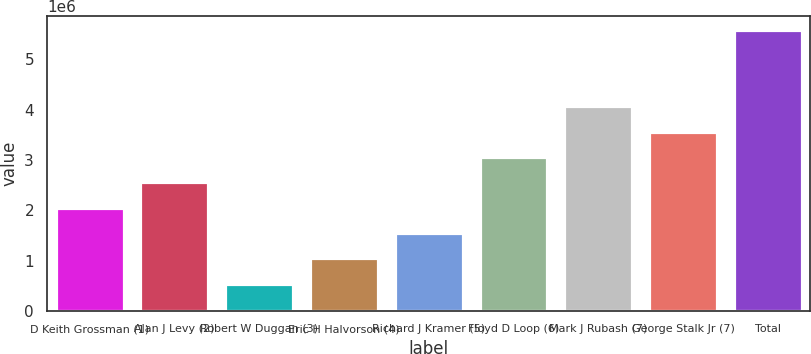<chart> <loc_0><loc_0><loc_500><loc_500><bar_chart><fcel>D Keith Grossman (1)<fcel>Alan J Levy (2)<fcel>Robert W Duggan (3)<fcel>Eric H Halvorson (4)<fcel>Richard J Kramer (5)<fcel>Floyd D Loop (6)<fcel>Mark J Rubash (7)<fcel>George Stalk Jr (7)<fcel>Total<nl><fcel>2.05164e+06<fcel>2.55489e+06<fcel>541904<fcel>1.04515e+06<fcel>1.5484e+06<fcel>3.05813e+06<fcel>4.06463e+06<fcel>3.56138e+06<fcel>5.57436e+06<nl></chart> 